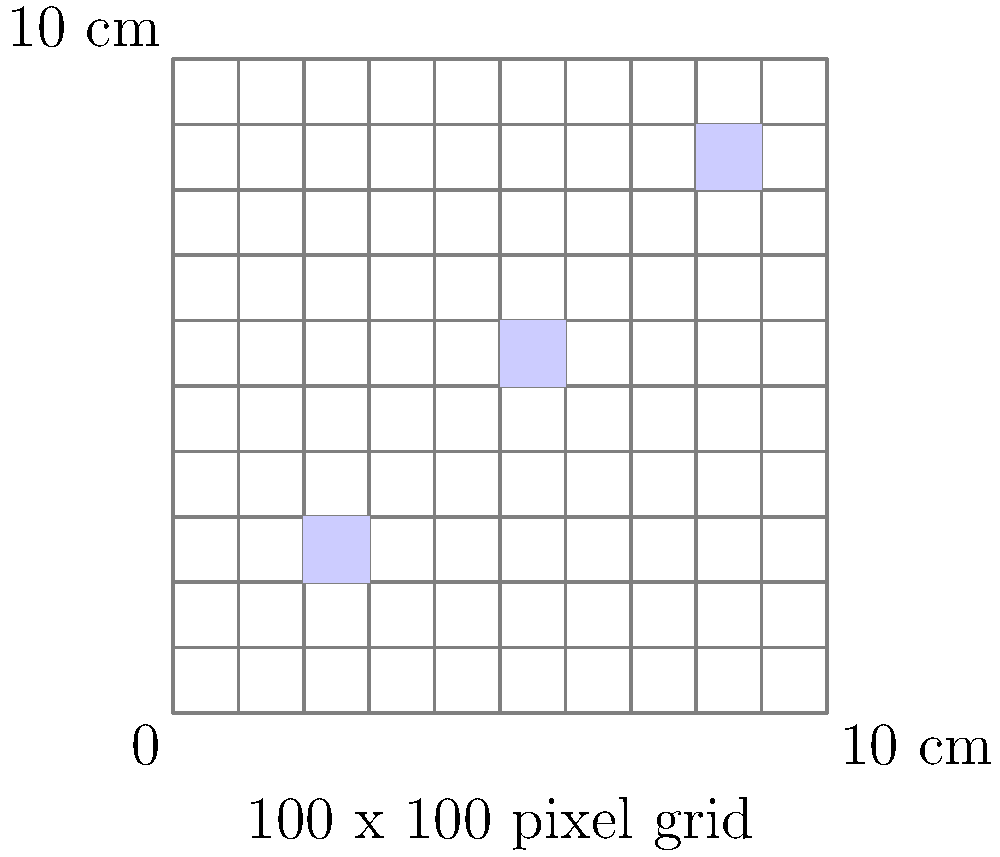In the early days of medical imaging, resolution was a critical factor. The image above represents a 10 cm x 10 cm medical scan divided into a 100 x 100 pixel grid. If three distinct features are detected (represented by the blue squares), what is the minimum resolution, in line pairs per centimeter (lp/cm), that this imaging system can resolve? To determine the minimum resolution, we need to follow these steps:

1) First, we need to understand what line pairs per centimeter (lp/cm) means. It's a measure of spatial resolution, where one line pair consists of one dark line and one light line.

2) In this image, the smallest detectable feature is represented by a single pixel. Two adjacent pixels (one dark, one light) would represent one line pair.

3) We need to calculate how many pixels are in 1 cm:
   - The grid is 100 pixels across 10 cm
   - So, pixels per cm = 100 pixels / 10 cm = 10 pixels/cm

4) Since one line pair requires two pixels, the number of line pairs per cm is half of the pixels per cm:
   $\text{lp/cm} = \frac{\text{pixels/cm}}{2} = \frac{10}{2} = 5 \text{ lp/cm}$

Therefore, the minimum resolution this system can resolve is 5 lp/cm.
Answer: 5 lp/cm 